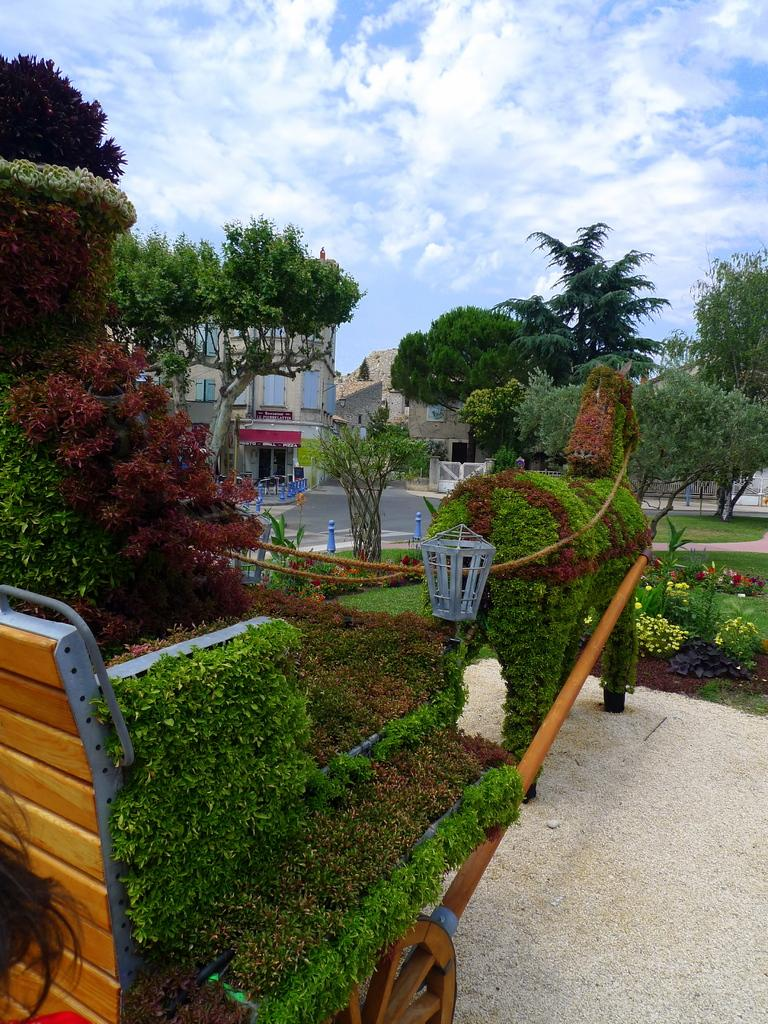What is the main subject of the image? There is a chariot in the image. What is attached to the chariot? A lamp is present on the chariot. What type of vegetation can be seen in the image? Creepers and trees are visible in the image. What type of pathway is in the image? There is a road in the image. What other living organism is present in the image? A plant is present in the image. What is visible at the top of the image? The sky is visible at the top of the image. What type of appliance can be seen on the chariot in the image? There is no appliance present on the chariot in the image; only a lamp is attached to it. Can you tell me how many frogs are sitting on the road in the image? There are no frogs present on the road in the image. 